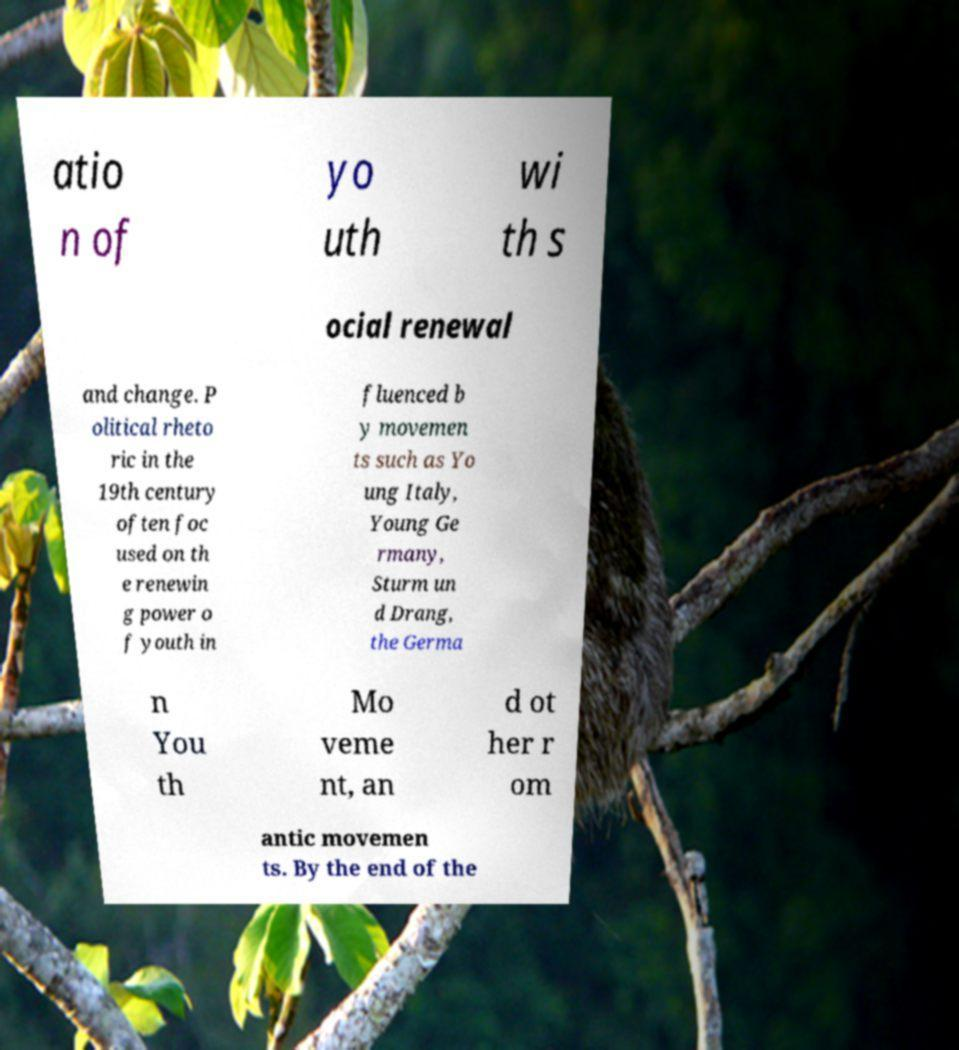I need the written content from this picture converted into text. Can you do that? atio n of yo uth wi th s ocial renewal and change. P olitical rheto ric in the 19th century often foc used on th e renewin g power o f youth in fluenced b y movemen ts such as Yo ung Italy, Young Ge rmany, Sturm un d Drang, the Germa n You th Mo veme nt, an d ot her r om antic movemen ts. By the end of the 